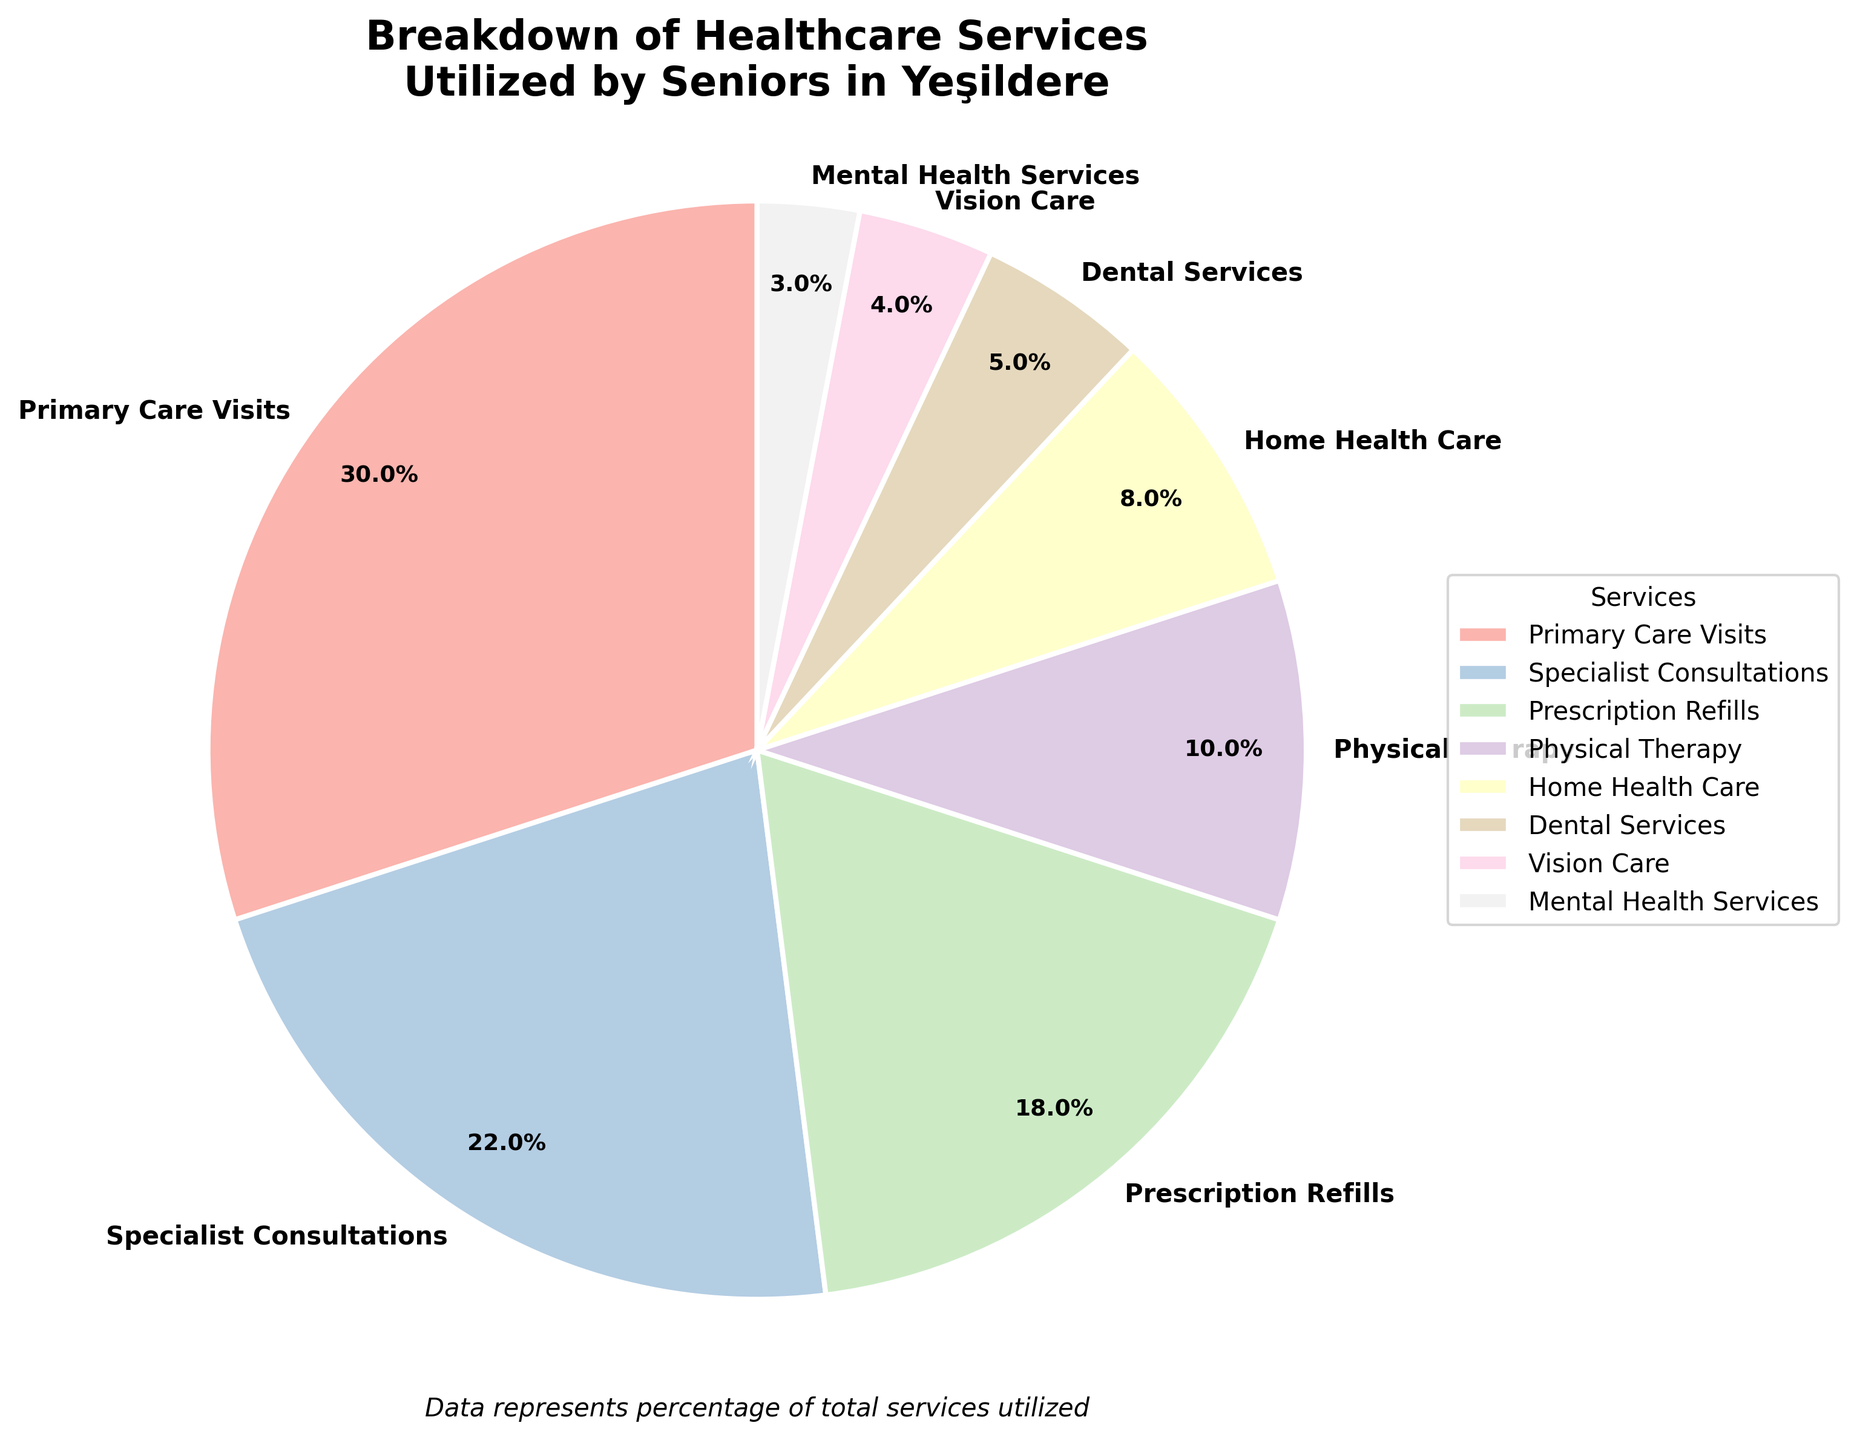What percentage of total healthcare services does Prescription Refills represent? By looking at the pie chart, each section represents a different service with its corresponding percentage. Locate the section labeled "Prescription Refills" to find its percentage.
Answer: 18% What is the combined percentage of Vision Care and Dental Services? To find the combined percentage, add the percentages of Vision Care and Dental Services. From the chart, Vision Care is 4% and Dental Services is 5%. So, 4% + 5% = 9%.
Answer: 9% Which service represents a larger proportion of utilization, Specialist Consultations or Home Health Care? Compare the percentages associated with Specialist Consultations and Home Health Care. From the chart, Specialist Consultations is 22%, and Home Health Care is 8%.
Answer: Specialist Consultations What is the difference in percentage between Mental Health Services and Physical Therapy? Subtract the percentage of Mental Health Services from the percentage of Physical Therapy. From the chart, Physical Therapy is 10%, and Mental Health Services is 3%. So, 10% - 3% = 7%.
Answer: 7% What service has the highest percentage, and what is that percentage? The largest section of the pie chart represents the service with the highest percentage. Look at the largest section and note the corresponding label and percentage.
Answer: Primary Care Visits, 30% How much more utilization is there for Primary Care Visits than Vision Care? Subtract the percentage of Vision Care from the percentage of Primary Care Visits. Primary Care Visits is 30%, and Vision Care is 4%. So, 30% - 4% = 26%.
Answer: 26% Are the combined percentages of Home Health Care and Mental Health Services more or less than Physical Therapy alone? Add the percentages of Home Health Care and Mental Health Services, then compare the sum to the percentage of Physical Therapy. Home Health Care is 8%, and Mental Health Services is 3%. Their sum is 8% + 3% = 11%, which is more than Physical Therapy's 10%.
Answer: More If the chart represents 100 total services, how many services does Home Health Care represent? Convert the percentage of Home Health Care to a count by multiplying the total number of services by the percentage in decimal form. Home Health Care is 8%, so 100 services * 0.08 = 8 services.
Answer: 8 services What is the rank of Physical Therapy in terms of service utilization percentage? Rank all services based on their percentage utilization. Physical Therapy with 10% falls after Prescription Refills (18%), Specialist Consultations (22%), and Primary Care Visits (30%), so it ranks 4th.
Answer: 4th What two services make up more than half of the total services utilized by seniors? Identify the services contributing the highest percentages and verify if their combined percentage exceeds 50%. Primary Care Visits (30%) and Specialist Consultations (22%) together account for 30% + 22% = 52%, which is more than half.
Answer: Primary Care Visits and Specialist Consultations 